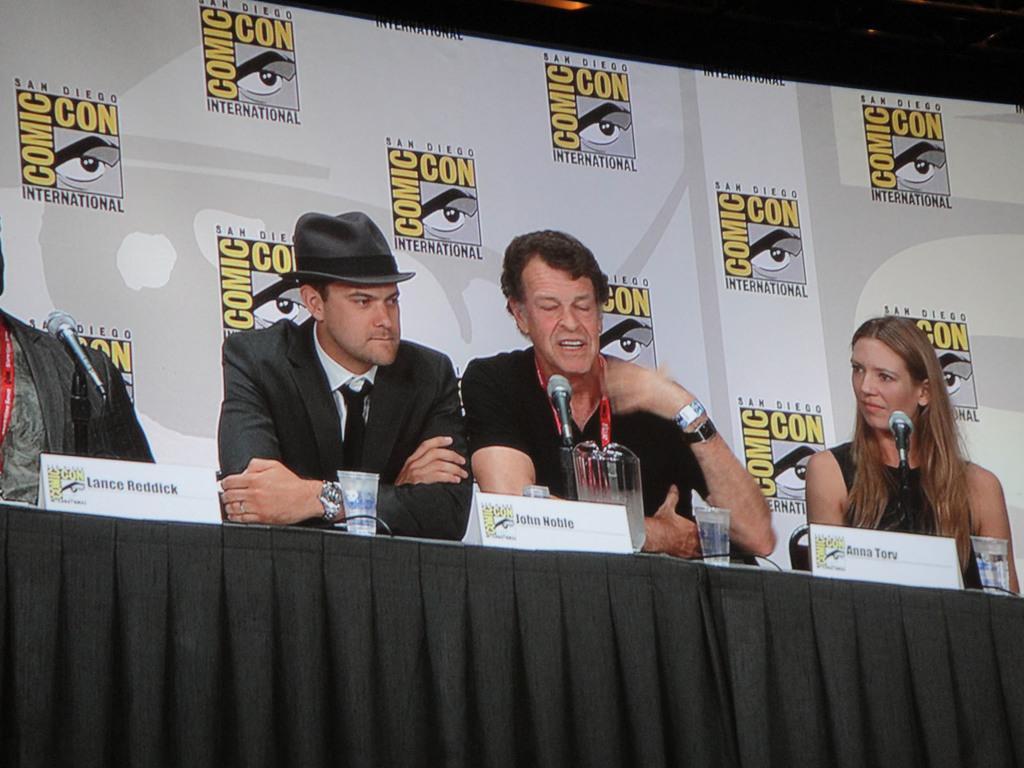Can you describe this image briefly? In this picture we can see few people are sitting, in front we can see the table, on which we can see some glasses, bottles and mike are arranged, behind we can see a banner. 